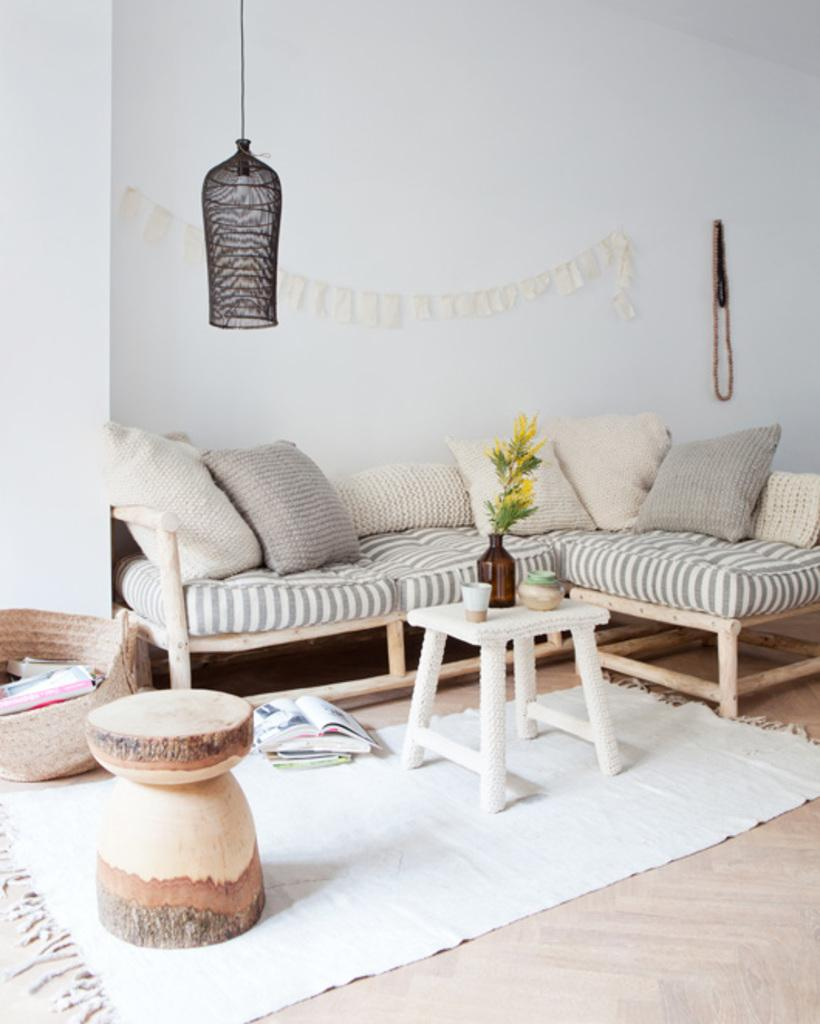What type of furniture is present in the image? There is a couch in the image. What can be found on the floor in the image? There are books on the floor in the image. Is there any greenery visible in the image? Yes, there is a plant in the image. Can you hear the ghost talking in the image? There is no ghost present in the image, so it is not possible to hear any talking. How old is the son in the image? There is no son present in the image, so it is not possible to determine his age. 